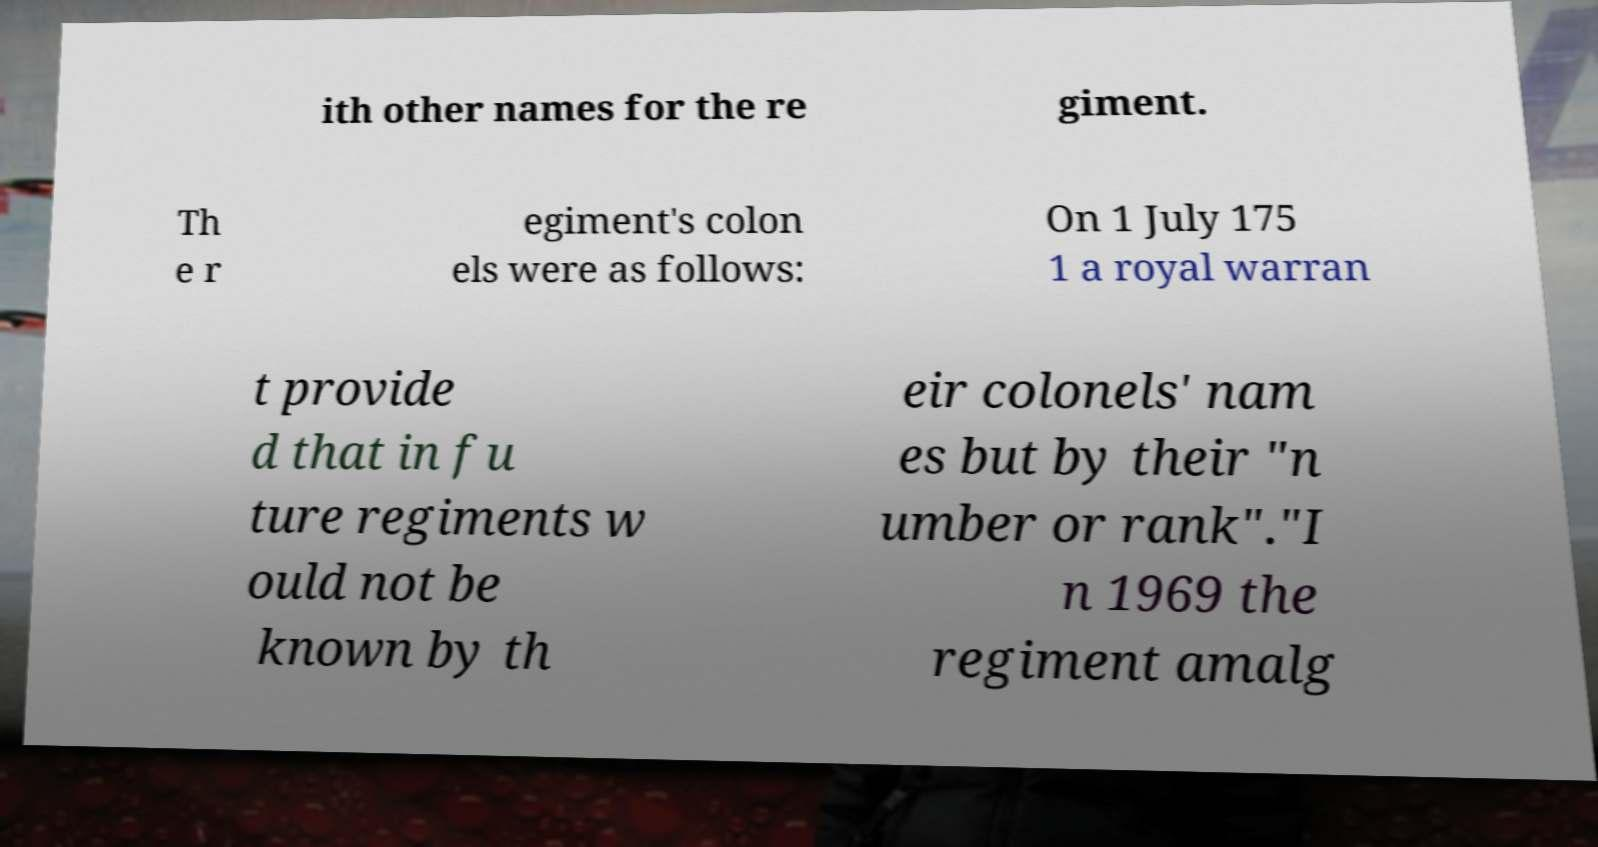For documentation purposes, I need the text within this image transcribed. Could you provide that? ith other names for the re giment. Th e r egiment's colon els were as follows: On 1 July 175 1 a royal warran t provide d that in fu ture regiments w ould not be known by th eir colonels' nam es but by their "n umber or rank"."I n 1969 the regiment amalg 